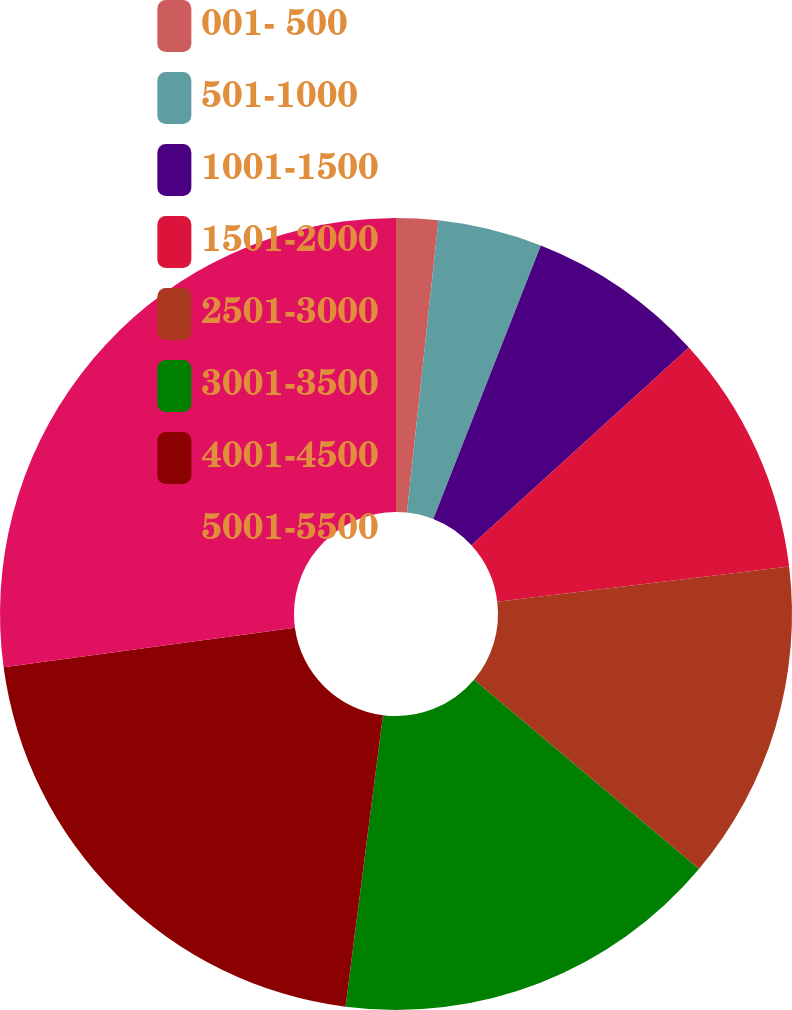Convert chart to OTSL. <chart><loc_0><loc_0><loc_500><loc_500><pie_chart><fcel>001- 500<fcel>501-1000<fcel>1001-1500<fcel>1501-2000<fcel>2501-3000<fcel>3001-3500<fcel>4001-4500<fcel>5001-5500<nl><fcel>1.71%<fcel>4.25%<fcel>7.29%<fcel>9.84%<fcel>13.05%<fcel>15.9%<fcel>20.82%<fcel>27.15%<nl></chart> 